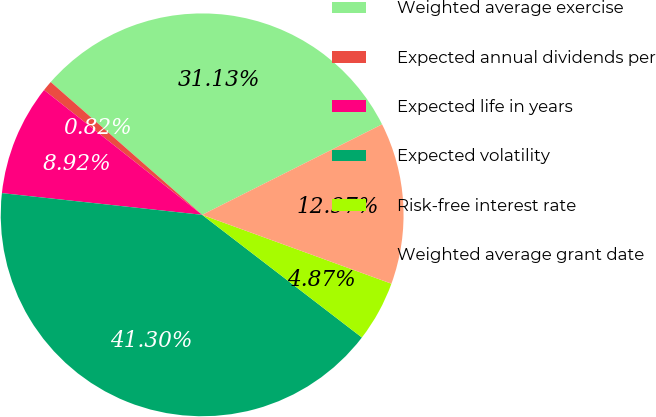Convert chart to OTSL. <chart><loc_0><loc_0><loc_500><loc_500><pie_chart><fcel>Weighted average exercise<fcel>Expected annual dividends per<fcel>Expected life in years<fcel>Expected volatility<fcel>Risk-free interest rate<fcel>Weighted average grant date<nl><fcel>31.13%<fcel>0.82%<fcel>8.92%<fcel>41.3%<fcel>4.87%<fcel>12.97%<nl></chart> 